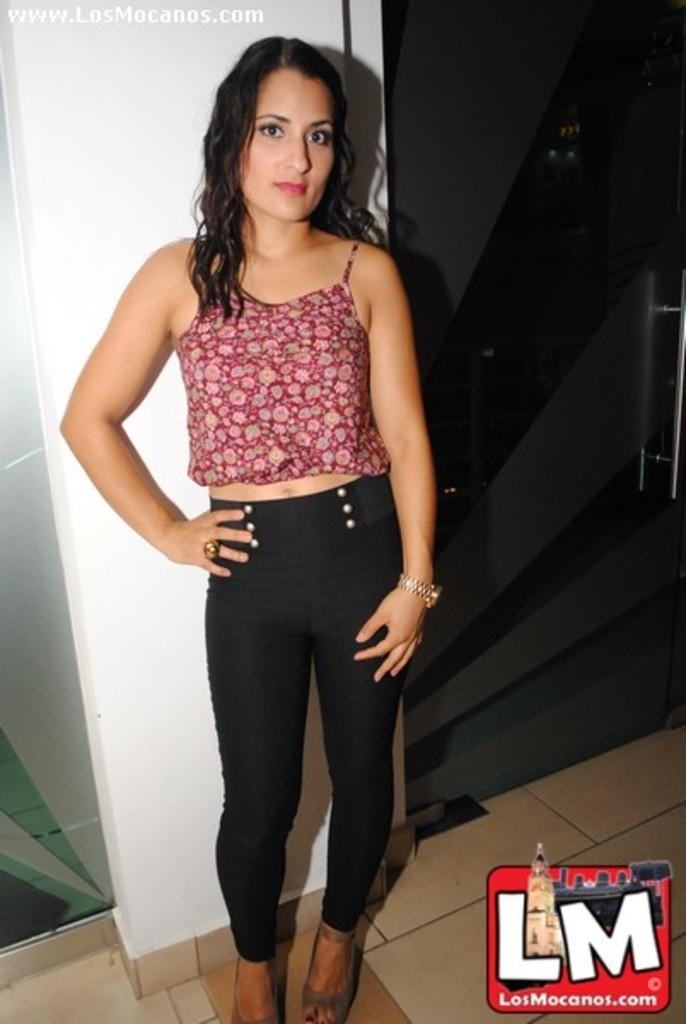What is the main subject of the image? There is a girl standing in the image. Where is the girl standing? The girl is standing on the floor. What is behind the girl? There is a wall and a glass door behind the girl. Is there any text or symbol in the image? Yes, there is a logo in the bottom right corner of the image. What is the girl's temper like in the image? There is no information about the girl's temper in the image. How many additional doors are present in the image? The facts provided only mention one glass door in the image. 